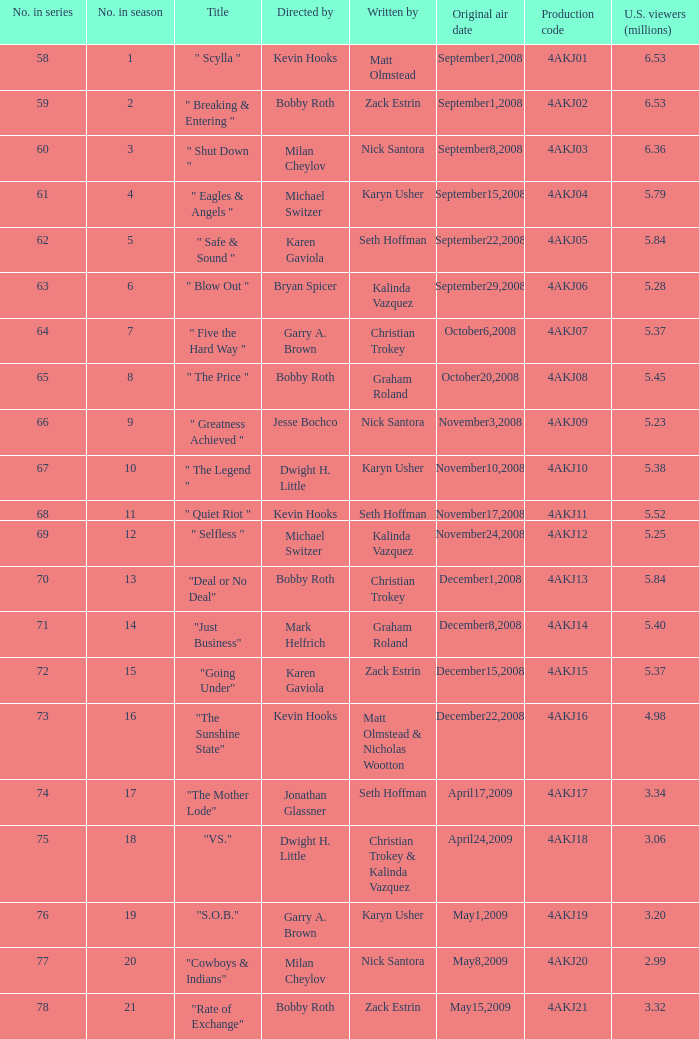Can you tell me the director of the episode labeled with production code 4akj08? Bobby Roth. 